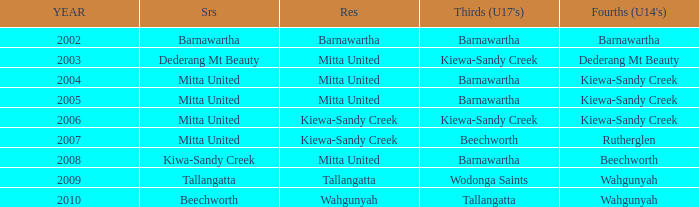Which Thirds (Under 17's) have a Reserve of barnawartha? Barnawartha. 